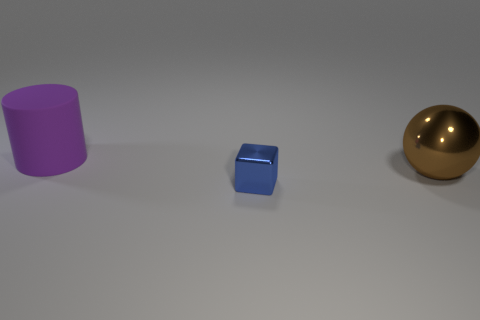Subtract all cubes. How many objects are left? 2 Add 3 red objects. How many objects exist? 6 Subtract 1 blocks. How many blocks are left? 0 Subtract 0 gray spheres. How many objects are left? 3 Subtract all cyan cylinders. Subtract all yellow blocks. How many cylinders are left? 1 Subtract all cyan cylinders. How many blue spheres are left? 0 Subtract all big metallic objects. Subtract all big purple metallic cubes. How many objects are left? 2 Add 3 blocks. How many blocks are left? 4 Add 1 purple cubes. How many purple cubes exist? 1 